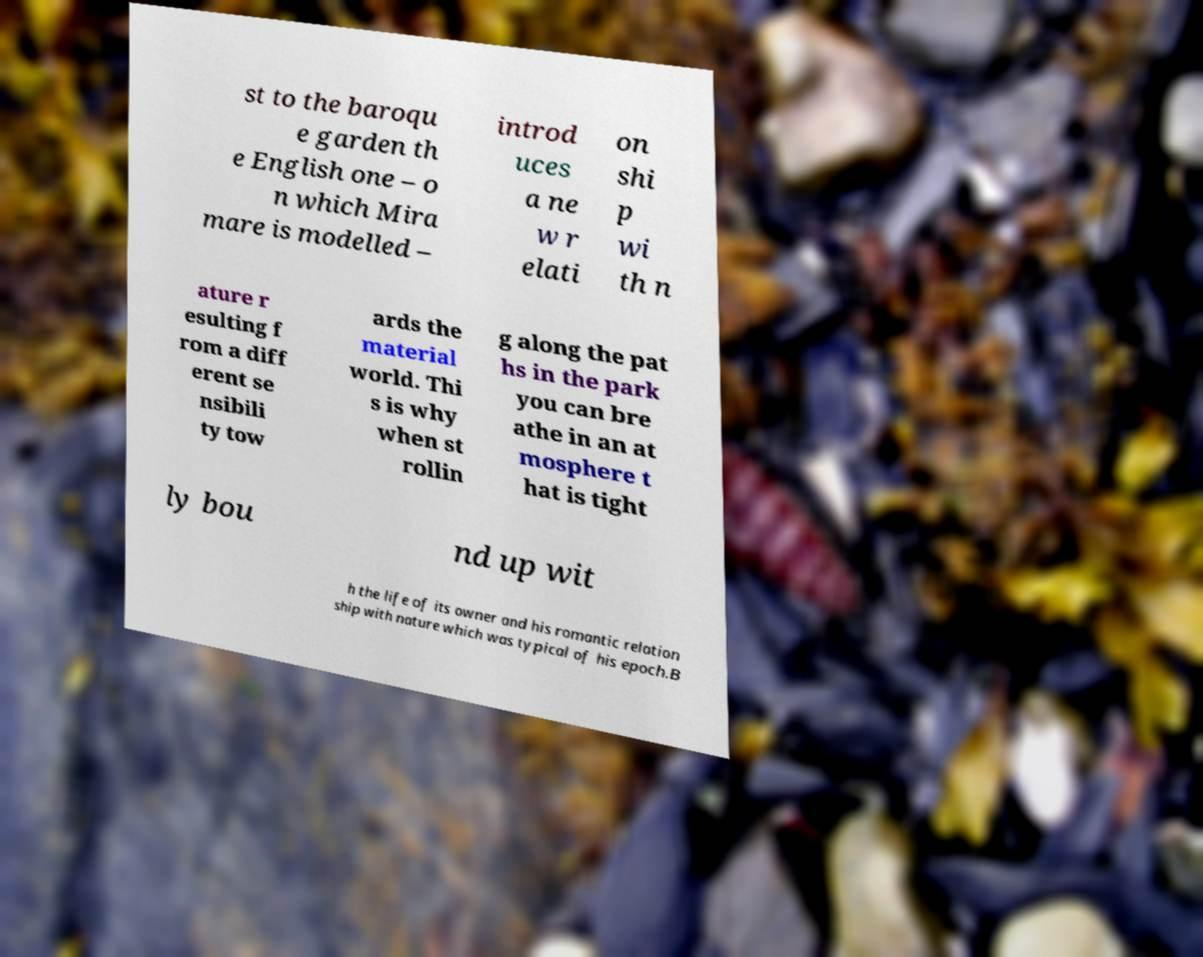Could you extract and type out the text from this image? st to the baroqu e garden th e English one – o n which Mira mare is modelled – introd uces a ne w r elati on shi p wi th n ature r esulting f rom a diff erent se nsibili ty tow ards the material world. Thi s is why when st rollin g along the pat hs in the park you can bre athe in an at mosphere t hat is tight ly bou nd up wit h the life of its owner and his romantic relation ship with nature which was typical of his epoch.B 